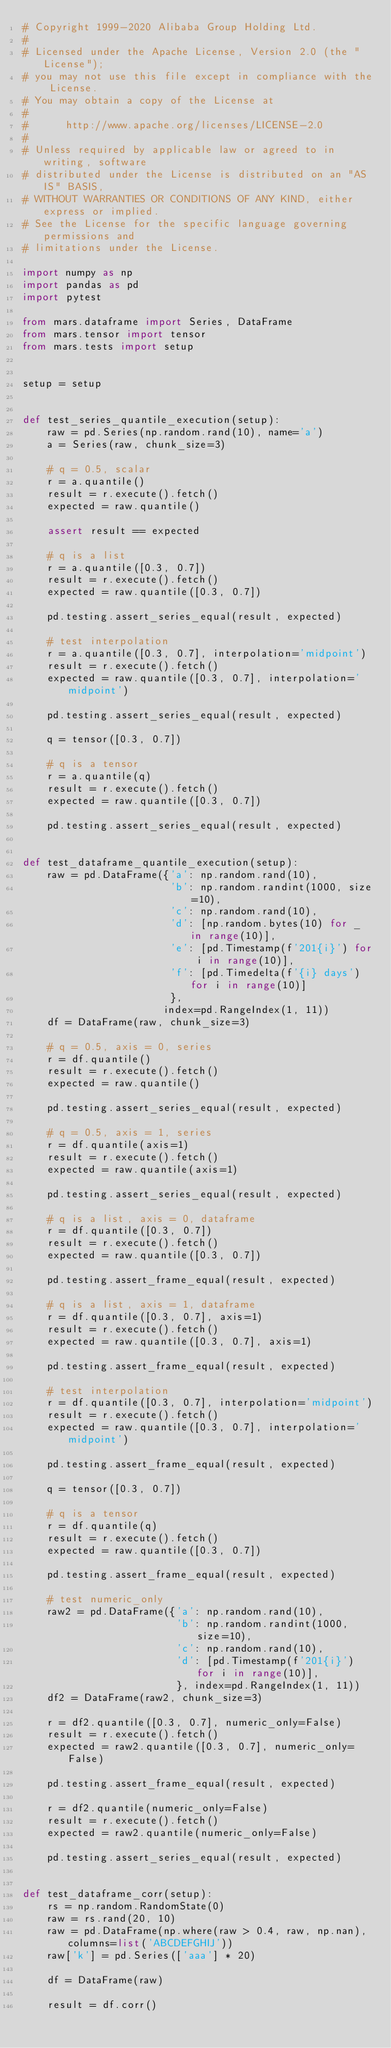<code> <loc_0><loc_0><loc_500><loc_500><_Python_># Copyright 1999-2020 Alibaba Group Holding Ltd.
#
# Licensed under the Apache License, Version 2.0 (the "License");
# you may not use this file except in compliance with the License.
# You may obtain a copy of the License at
#
#      http://www.apache.org/licenses/LICENSE-2.0
#
# Unless required by applicable law or agreed to in writing, software
# distributed under the License is distributed on an "AS IS" BASIS,
# WITHOUT WARRANTIES OR CONDITIONS OF ANY KIND, either express or implied.
# See the License for the specific language governing permissions and
# limitations under the License.

import numpy as np
import pandas as pd
import pytest

from mars.dataframe import Series, DataFrame
from mars.tensor import tensor
from mars.tests import setup


setup = setup


def test_series_quantile_execution(setup):
    raw = pd.Series(np.random.rand(10), name='a')
    a = Series(raw, chunk_size=3)

    # q = 0.5, scalar
    r = a.quantile()
    result = r.execute().fetch()
    expected = raw.quantile()

    assert result == expected

    # q is a list
    r = a.quantile([0.3, 0.7])
    result = r.execute().fetch()
    expected = raw.quantile([0.3, 0.7])

    pd.testing.assert_series_equal(result, expected)

    # test interpolation
    r = a.quantile([0.3, 0.7], interpolation='midpoint')
    result = r.execute().fetch()
    expected = raw.quantile([0.3, 0.7], interpolation='midpoint')

    pd.testing.assert_series_equal(result, expected)

    q = tensor([0.3, 0.7])

    # q is a tensor
    r = a.quantile(q)
    result = r.execute().fetch()
    expected = raw.quantile([0.3, 0.7])

    pd.testing.assert_series_equal(result, expected)


def test_dataframe_quantile_execution(setup):
    raw = pd.DataFrame({'a': np.random.rand(10),
                        'b': np.random.randint(1000, size=10),
                        'c': np.random.rand(10),
                        'd': [np.random.bytes(10) for _ in range(10)],
                        'e': [pd.Timestamp(f'201{i}') for i in range(10)],
                        'f': [pd.Timedelta(f'{i} days') for i in range(10)]
                        },
                       index=pd.RangeIndex(1, 11))
    df = DataFrame(raw, chunk_size=3)

    # q = 0.5, axis = 0, series
    r = df.quantile()
    result = r.execute().fetch()
    expected = raw.quantile()

    pd.testing.assert_series_equal(result, expected)

    # q = 0.5, axis = 1, series
    r = df.quantile(axis=1)
    result = r.execute().fetch()
    expected = raw.quantile(axis=1)

    pd.testing.assert_series_equal(result, expected)

    # q is a list, axis = 0, dataframe
    r = df.quantile([0.3, 0.7])
    result = r.execute().fetch()
    expected = raw.quantile([0.3, 0.7])

    pd.testing.assert_frame_equal(result, expected)

    # q is a list, axis = 1, dataframe
    r = df.quantile([0.3, 0.7], axis=1)
    result = r.execute().fetch()
    expected = raw.quantile([0.3, 0.7], axis=1)

    pd.testing.assert_frame_equal(result, expected)

    # test interpolation
    r = df.quantile([0.3, 0.7], interpolation='midpoint')
    result = r.execute().fetch()
    expected = raw.quantile([0.3, 0.7], interpolation='midpoint')

    pd.testing.assert_frame_equal(result, expected)

    q = tensor([0.3, 0.7])

    # q is a tensor
    r = df.quantile(q)
    result = r.execute().fetch()
    expected = raw.quantile([0.3, 0.7])

    pd.testing.assert_frame_equal(result, expected)

    # test numeric_only
    raw2 = pd.DataFrame({'a': np.random.rand(10),
                         'b': np.random.randint(1000, size=10),
                         'c': np.random.rand(10),
                         'd': [pd.Timestamp(f'201{i}') for i in range(10)],
                         }, index=pd.RangeIndex(1, 11))
    df2 = DataFrame(raw2, chunk_size=3)

    r = df2.quantile([0.3, 0.7], numeric_only=False)
    result = r.execute().fetch()
    expected = raw2.quantile([0.3, 0.7], numeric_only=False)

    pd.testing.assert_frame_equal(result, expected)

    r = df2.quantile(numeric_only=False)
    result = r.execute().fetch()
    expected = raw2.quantile(numeric_only=False)

    pd.testing.assert_series_equal(result, expected)


def test_dataframe_corr(setup):
    rs = np.random.RandomState(0)
    raw = rs.rand(20, 10)
    raw = pd.DataFrame(np.where(raw > 0.4, raw, np.nan), columns=list('ABCDEFGHIJ'))
    raw['k'] = pd.Series(['aaa'] * 20)

    df = DataFrame(raw)

    result = df.corr()</code> 